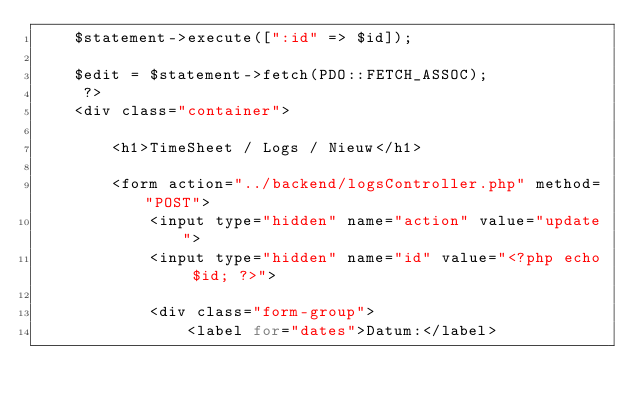<code> <loc_0><loc_0><loc_500><loc_500><_PHP_>    $statement->execute([":id" => $id]);
    
    $edit = $statement->fetch(PDO::FETCH_ASSOC);
     ?>
    <div class="container">

        <h1>TimeSheet / Logs / Nieuw</h1>

        <form action="../backend/logsController.php" method="POST">
            <input type="hidden" name="action" value="update">
            <input type="hidden" name="id" value="<?php echo $id; ?>">
        
            <div class="form-group">
                <label for="dates">Datum:</label></code> 